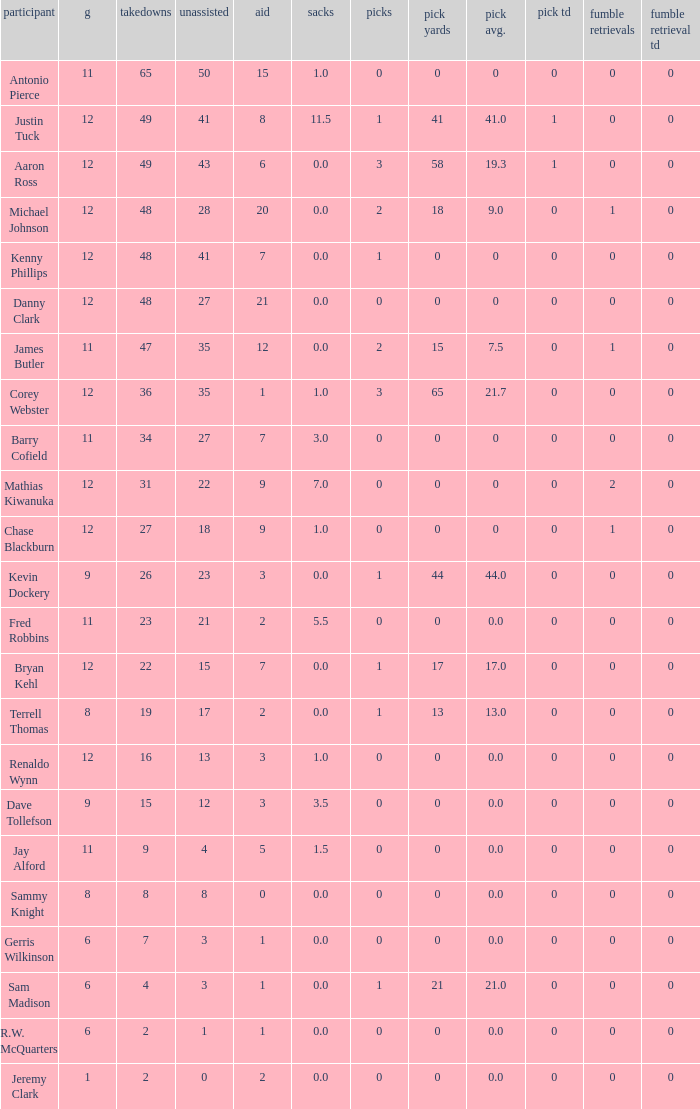Identify the smallest quantity of whole number yards. 0.0. Could you parse the entire table? {'header': ['participant', 'g', 'takedowns', 'unassisted', 'aid', 'sacks', 'picks', 'pick yards', 'pick avg.', 'pick td', 'fumble retrievals', 'fumble retrieval td'], 'rows': [['Antonio Pierce', '11', '65', '50', '15', '1.0', '0', '0', '0', '0', '0', '0'], ['Justin Tuck', '12', '49', '41', '8', '11.5', '1', '41', '41.0', '1', '0', '0'], ['Aaron Ross', '12', '49', '43', '6', '0.0', '3', '58', '19.3', '1', '0', '0'], ['Michael Johnson', '12', '48', '28', '20', '0.0', '2', '18', '9.0', '0', '1', '0'], ['Kenny Phillips', '12', '48', '41', '7', '0.0', '1', '0', '0', '0', '0', '0'], ['Danny Clark', '12', '48', '27', '21', '0.0', '0', '0', '0', '0', '0', '0'], ['James Butler', '11', '47', '35', '12', '0.0', '2', '15', '7.5', '0', '1', '0'], ['Corey Webster', '12', '36', '35', '1', '1.0', '3', '65', '21.7', '0', '0', '0'], ['Barry Cofield', '11', '34', '27', '7', '3.0', '0', '0', '0', '0', '0', '0'], ['Mathias Kiwanuka', '12', '31', '22', '9', '7.0', '0', '0', '0', '0', '2', '0'], ['Chase Blackburn', '12', '27', '18', '9', '1.0', '0', '0', '0', '0', '1', '0'], ['Kevin Dockery', '9', '26', '23', '3', '0.0', '1', '44', '44.0', '0', '0', '0'], ['Fred Robbins', '11', '23', '21', '2', '5.5', '0', '0', '0.0', '0', '0', '0'], ['Bryan Kehl', '12', '22', '15', '7', '0.0', '1', '17', '17.0', '0', '0', '0'], ['Terrell Thomas', '8', '19', '17', '2', '0.0', '1', '13', '13.0', '0', '0', '0'], ['Renaldo Wynn', '12', '16', '13', '3', '1.0', '0', '0', '0.0', '0', '0', '0'], ['Dave Tollefson', '9', '15', '12', '3', '3.5', '0', '0', '0.0', '0', '0', '0'], ['Jay Alford', '11', '9', '4', '5', '1.5', '0', '0', '0.0', '0', '0', '0'], ['Sammy Knight', '8', '8', '8', '0', '0.0', '0', '0', '0.0', '0', '0', '0'], ['Gerris Wilkinson', '6', '7', '3', '1', '0.0', '0', '0', '0.0', '0', '0', '0'], ['Sam Madison', '6', '4', '3', '1', '0.0', '1', '21', '21.0', '0', '0', '0'], ['R.W. McQuarters', '6', '2', '1', '1', '0.0', '0', '0', '0.0', '0', '0', '0'], ['Jeremy Clark', '1', '2', '0', '2', '0.0', '0', '0', '0.0', '0', '0', '0']]} 